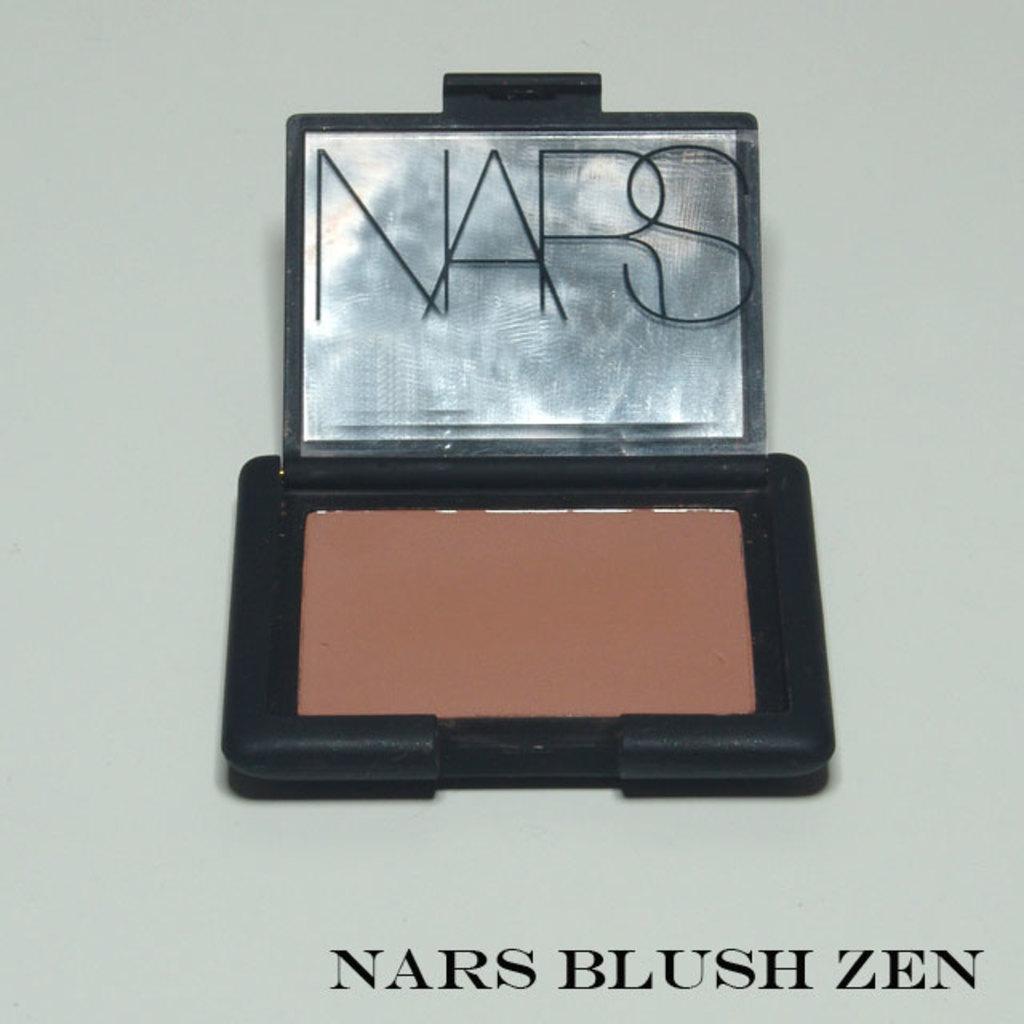What type of product is displayed?
Keep it short and to the point. Nars blush zen. What is the name of this blush?
Give a very brief answer. Nars. 